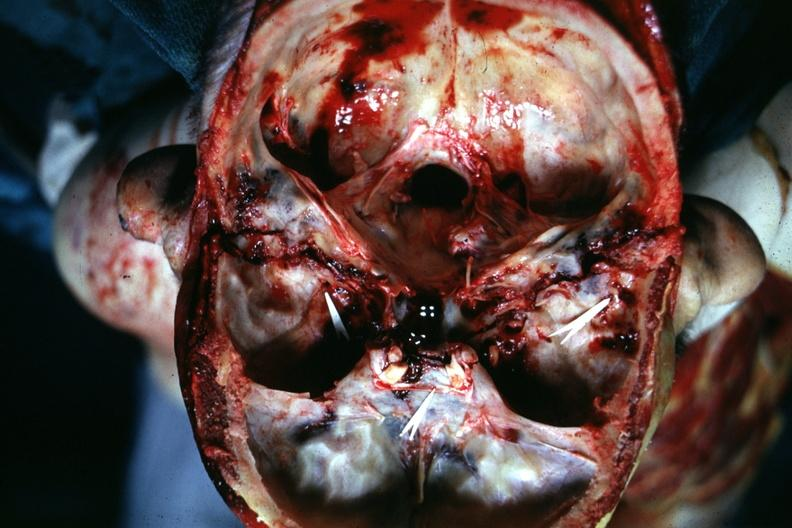s basilar skull fracture present?
Answer the question using a single word or phrase. Yes 